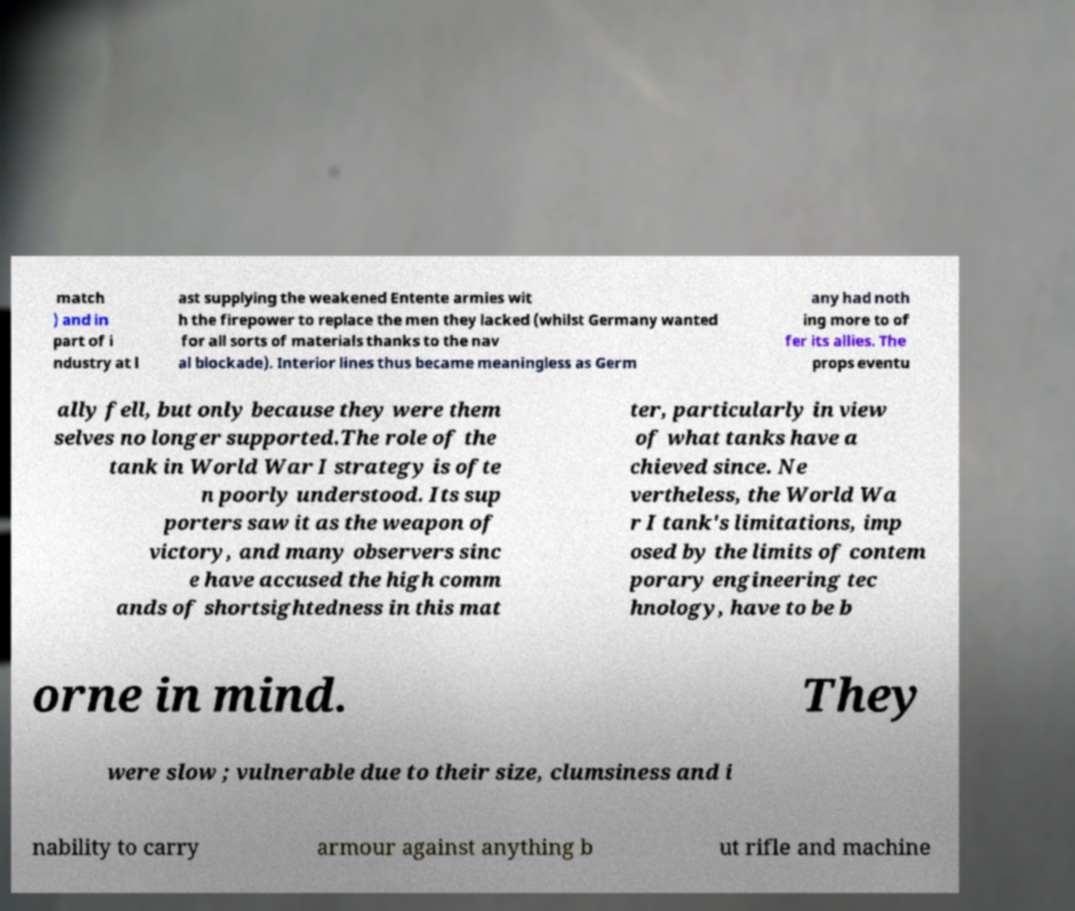There's text embedded in this image that I need extracted. Can you transcribe it verbatim? match ) and in part of i ndustry at l ast supplying the weakened Entente armies wit h the firepower to replace the men they lacked (whilst Germany wanted for all sorts of materials thanks to the nav al blockade). Interior lines thus became meaningless as Germ any had noth ing more to of fer its allies. The props eventu ally fell, but only because they were them selves no longer supported.The role of the tank in World War I strategy is ofte n poorly understood. Its sup porters saw it as the weapon of victory, and many observers sinc e have accused the high comm ands of shortsightedness in this mat ter, particularly in view of what tanks have a chieved since. Ne vertheless, the World Wa r I tank's limitations, imp osed by the limits of contem porary engineering tec hnology, have to be b orne in mind. They were slow ; vulnerable due to their size, clumsiness and i nability to carry armour against anything b ut rifle and machine 